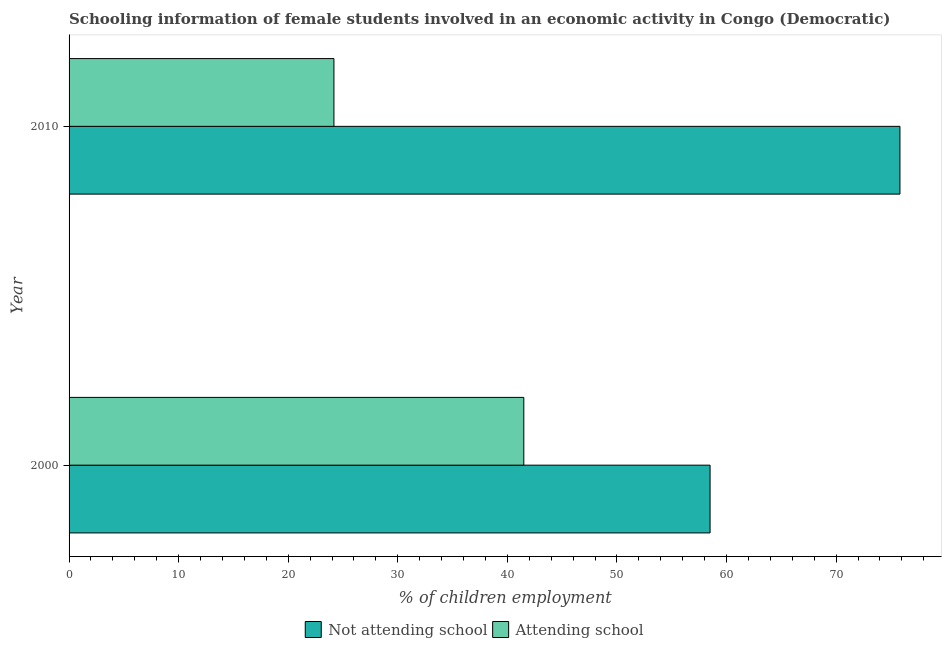How many different coloured bars are there?
Offer a very short reply. 2. How many groups of bars are there?
Offer a terse response. 2. Are the number of bars on each tick of the Y-axis equal?
Provide a succinct answer. Yes. How many bars are there on the 2nd tick from the bottom?
Provide a short and direct response. 2. What is the label of the 1st group of bars from the top?
Offer a very short reply. 2010. In how many cases, is the number of bars for a given year not equal to the number of legend labels?
Offer a terse response. 0. What is the percentage of employed females who are not attending school in 2010?
Make the answer very short. 75.83. Across all years, what is the maximum percentage of employed females who are attending school?
Make the answer very short. 41.5. Across all years, what is the minimum percentage of employed females who are attending school?
Provide a succinct answer. 24.17. What is the total percentage of employed females who are attending school in the graph?
Ensure brevity in your answer.  65.67. What is the difference between the percentage of employed females who are not attending school in 2000 and that in 2010?
Your answer should be very brief. -17.33. What is the difference between the percentage of employed females who are attending school in 2000 and the percentage of employed females who are not attending school in 2010?
Give a very brief answer. -34.33. What is the average percentage of employed females who are not attending school per year?
Your answer should be very brief. 67.16. In the year 2010, what is the difference between the percentage of employed females who are not attending school and percentage of employed females who are attending school?
Your answer should be compact. 51.66. In how many years, is the percentage of employed females who are not attending school greater than 42 %?
Provide a succinct answer. 2. What is the ratio of the percentage of employed females who are not attending school in 2000 to that in 2010?
Provide a short and direct response. 0.77. What does the 2nd bar from the top in 2010 represents?
Offer a very short reply. Not attending school. What does the 2nd bar from the bottom in 2000 represents?
Your answer should be very brief. Attending school. Are all the bars in the graph horizontal?
Keep it short and to the point. Yes. What is the difference between two consecutive major ticks on the X-axis?
Provide a short and direct response. 10. Does the graph contain any zero values?
Provide a succinct answer. No. Does the graph contain grids?
Your answer should be very brief. No. How are the legend labels stacked?
Ensure brevity in your answer.  Horizontal. What is the title of the graph?
Your answer should be compact. Schooling information of female students involved in an economic activity in Congo (Democratic). What is the label or title of the X-axis?
Provide a short and direct response. % of children employment. What is the label or title of the Y-axis?
Provide a short and direct response. Year. What is the % of children employment of Not attending school in 2000?
Give a very brief answer. 58.5. What is the % of children employment in Attending school in 2000?
Your response must be concise. 41.5. What is the % of children employment in Not attending school in 2010?
Keep it short and to the point. 75.83. What is the % of children employment in Attending school in 2010?
Provide a succinct answer. 24.17. Across all years, what is the maximum % of children employment in Not attending school?
Your answer should be very brief. 75.83. Across all years, what is the maximum % of children employment in Attending school?
Offer a very short reply. 41.5. Across all years, what is the minimum % of children employment of Not attending school?
Keep it short and to the point. 58.5. Across all years, what is the minimum % of children employment of Attending school?
Your response must be concise. 24.17. What is the total % of children employment of Not attending school in the graph?
Your response must be concise. 134.33. What is the total % of children employment in Attending school in the graph?
Ensure brevity in your answer.  65.67. What is the difference between the % of children employment of Not attending school in 2000 and that in 2010?
Offer a terse response. -17.33. What is the difference between the % of children employment of Attending school in 2000 and that in 2010?
Provide a short and direct response. 17.33. What is the difference between the % of children employment of Not attending school in 2000 and the % of children employment of Attending school in 2010?
Your response must be concise. 34.33. What is the average % of children employment in Not attending school per year?
Your answer should be very brief. 67.16. What is the average % of children employment of Attending school per year?
Make the answer very short. 32.84. In the year 2000, what is the difference between the % of children employment in Not attending school and % of children employment in Attending school?
Ensure brevity in your answer.  17. In the year 2010, what is the difference between the % of children employment in Not attending school and % of children employment in Attending school?
Give a very brief answer. 51.66. What is the ratio of the % of children employment of Not attending school in 2000 to that in 2010?
Make the answer very short. 0.77. What is the ratio of the % of children employment in Attending school in 2000 to that in 2010?
Give a very brief answer. 1.72. What is the difference between the highest and the second highest % of children employment in Not attending school?
Provide a short and direct response. 17.33. What is the difference between the highest and the second highest % of children employment in Attending school?
Ensure brevity in your answer.  17.33. What is the difference between the highest and the lowest % of children employment of Not attending school?
Give a very brief answer. 17.33. What is the difference between the highest and the lowest % of children employment in Attending school?
Keep it short and to the point. 17.33. 